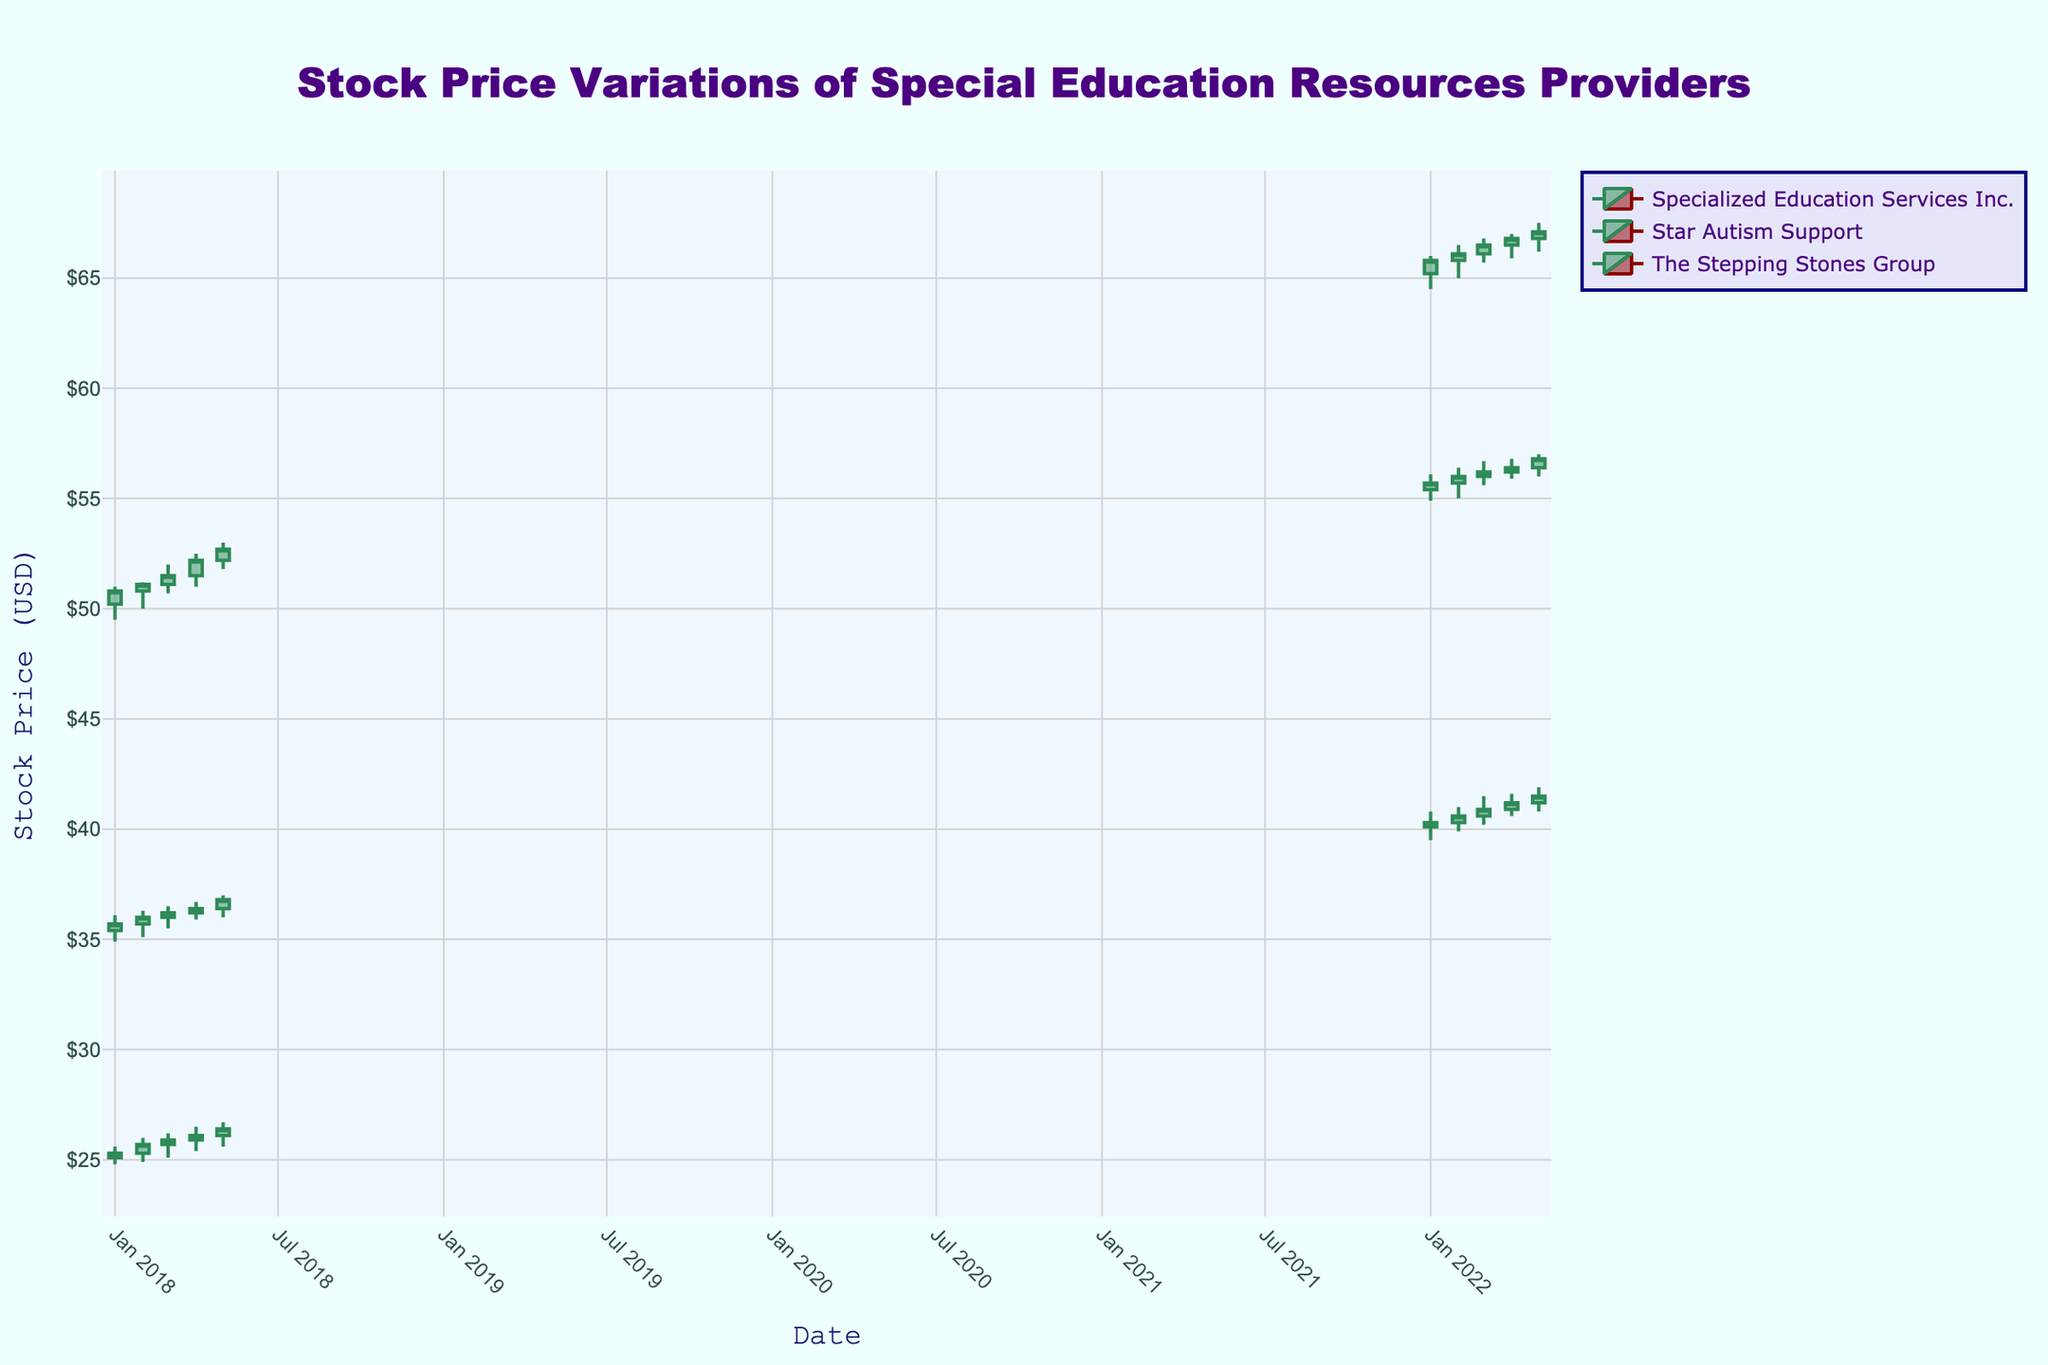What is the title of the figure? The title is usually displayed at the top of the figure. In this case, the title is specified in the code as 'Stock Price Variations of Special Education Resources Providers'.
Answer: Stock Price Variations of Special Education Resources Providers What colors are used to indicate increasing and decreasing prices in the candlestick chart? In the figure, the code specifies 'Sea Green' for increasing prices and 'Dark Red' for decreasing prices. These colors can be identified by looking at the candlestick bodies in the figure.
Answer: Sea Green and Dark Red Which company has the highest closing price in January 2022? To find the highest closing price in January 2022, look at the closing prices mentioned for each company in that month. Star Autism Support has a closing price of $65.80, which is the highest.
Answer: Star Autism Support What is the general trend of Specialized Education Services Inc.'s stock prices from January 2018 to May 2018? Look at the candlestick segments for Specialized Education Services Inc. from January to May 2018 to determine if the prices are generally increasing, decreasing, or fluctuating. The prices show a general increasing trend from $25.10 to $26.40.
Answer: Increasing How does The Stepping Stones Group's stock price variation in January 2022 compare to January 2018? Compare the candlestick bodies for The Stepping Stones Group in January 2018 and January 2022. The closing price in January 2022 ($55.70) is higher than in January 2018 ($35.70).
Answer: Higher in January 2022 What is the average closing price for Star Autism Support from January 2022 to May 2022? Sum the closing prices for each month and divide by the number of months. ($65.80 + $66.10 + $66.50 + $66.80 + $67.10) / 5 = $66.46
Answer: $66.46 Which company had the highest trading volume in April 2018? Look at the 'Volume' column for each company in April 2018. Star Autism Support had the highest volume with 250,000.
Answer: Star Autism Support How did the volume of trades for Specialized Education Services Inc. change from January 2022 to May 2022? Check the volume values for each month from January to May 2022. The volumes are 180,000, 200,000, 185,000, 165,000, and 205,000, respectively, showing fluctuations with a peak in May.
Answer: Fluctuating with a peak in May What is the difference between the highest and lowest closing prices for The Stepping Stones Group in 2022 data? Identify the high and low closing prices for The Stepping Stones Group in 2022. The highest is $56.80 and the lowest is $55.70. The difference is 56.80 - 55.70 = $1.10.
Answer: $1.10 Which company showed a more consistent increase in stock prices from January to May 2018? Compare the closing prices month-by-month for the companies from January to May 2018. Star Autism Support shows a more consistent increase from $50.80 to $52.70.
Answer: Star Autism Support 